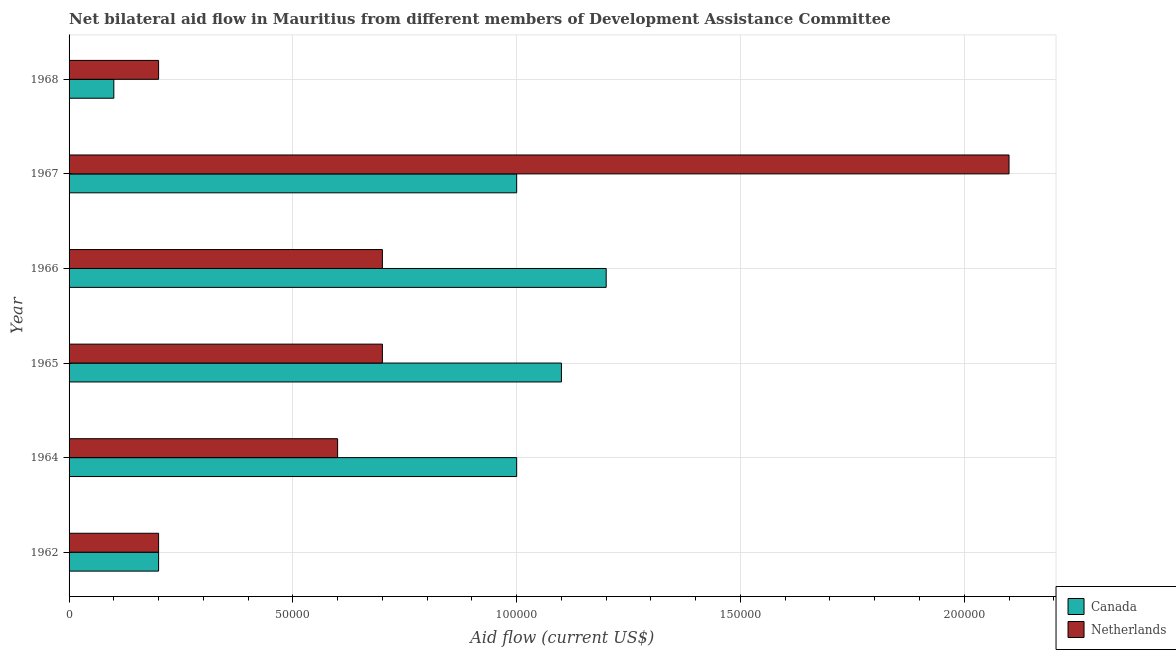How many groups of bars are there?
Provide a succinct answer. 6. Are the number of bars on each tick of the Y-axis equal?
Your response must be concise. Yes. How many bars are there on the 5th tick from the bottom?
Your answer should be compact. 2. What is the label of the 4th group of bars from the top?
Your answer should be compact. 1965. In how many cases, is the number of bars for a given year not equal to the number of legend labels?
Your answer should be very brief. 0. What is the amount of aid given by netherlands in 1962?
Provide a succinct answer. 2.00e+04. Across all years, what is the maximum amount of aid given by netherlands?
Give a very brief answer. 2.10e+05. Across all years, what is the minimum amount of aid given by netherlands?
Make the answer very short. 2.00e+04. In which year was the amount of aid given by canada maximum?
Offer a terse response. 1966. In which year was the amount of aid given by netherlands minimum?
Provide a short and direct response. 1962. What is the total amount of aid given by canada in the graph?
Give a very brief answer. 4.60e+05. What is the difference between the amount of aid given by netherlands in 1965 and that in 1966?
Provide a succinct answer. 0. What is the difference between the amount of aid given by canada in 1965 and the amount of aid given by netherlands in 1967?
Provide a short and direct response. -1.00e+05. What is the average amount of aid given by canada per year?
Provide a short and direct response. 7.67e+04. In the year 1965, what is the difference between the amount of aid given by netherlands and amount of aid given by canada?
Provide a succinct answer. -4.00e+04. In how many years, is the amount of aid given by netherlands greater than 120000 US$?
Your answer should be very brief. 1. What is the ratio of the amount of aid given by canada in 1967 to that in 1968?
Your answer should be very brief. 10. What is the difference between the highest and the lowest amount of aid given by netherlands?
Your answer should be compact. 1.90e+05. Is the sum of the amount of aid given by netherlands in 1965 and 1968 greater than the maximum amount of aid given by canada across all years?
Provide a succinct answer. No. What does the 1st bar from the top in 1967 represents?
Your response must be concise. Netherlands. What does the 2nd bar from the bottom in 1967 represents?
Make the answer very short. Netherlands. How many bars are there?
Keep it short and to the point. 12. Are all the bars in the graph horizontal?
Offer a very short reply. Yes. Does the graph contain any zero values?
Provide a succinct answer. No. Does the graph contain grids?
Keep it short and to the point. Yes. Where does the legend appear in the graph?
Provide a short and direct response. Bottom right. What is the title of the graph?
Ensure brevity in your answer.  Net bilateral aid flow in Mauritius from different members of Development Assistance Committee. Does "Services" appear as one of the legend labels in the graph?
Provide a short and direct response. No. What is the label or title of the Y-axis?
Your response must be concise. Year. What is the Aid flow (current US$) of Canada in 1962?
Ensure brevity in your answer.  2.00e+04. What is the Aid flow (current US$) in Netherlands in 1962?
Ensure brevity in your answer.  2.00e+04. What is the Aid flow (current US$) of Canada in 1965?
Provide a succinct answer. 1.10e+05. What is the Aid flow (current US$) of Netherlands in 1965?
Ensure brevity in your answer.  7.00e+04. What is the Aid flow (current US$) of Canada in 1966?
Keep it short and to the point. 1.20e+05. What is the Aid flow (current US$) of Netherlands in 1966?
Ensure brevity in your answer.  7.00e+04. What is the Aid flow (current US$) of Canada in 1967?
Your answer should be compact. 1.00e+05. What is the Aid flow (current US$) in Netherlands in 1968?
Offer a terse response. 2.00e+04. Across all years, what is the maximum Aid flow (current US$) of Canada?
Provide a succinct answer. 1.20e+05. Across all years, what is the maximum Aid flow (current US$) of Netherlands?
Give a very brief answer. 2.10e+05. Across all years, what is the minimum Aid flow (current US$) in Netherlands?
Your answer should be compact. 2.00e+04. What is the difference between the Aid flow (current US$) of Netherlands in 1962 and that in 1964?
Offer a terse response. -4.00e+04. What is the difference between the Aid flow (current US$) in Netherlands in 1962 and that in 1965?
Keep it short and to the point. -5.00e+04. What is the difference between the Aid flow (current US$) of Canada in 1962 and that in 1967?
Make the answer very short. -8.00e+04. What is the difference between the Aid flow (current US$) of Netherlands in 1964 and that in 1966?
Give a very brief answer. -10000. What is the difference between the Aid flow (current US$) of Canada in 1964 and that in 1967?
Your answer should be compact. 0. What is the difference between the Aid flow (current US$) of Netherlands in 1964 and that in 1967?
Offer a terse response. -1.50e+05. What is the difference between the Aid flow (current US$) of Canada in 1964 and that in 1968?
Offer a terse response. 9.00e+04. What is the difference between the Aid flow (current US$) in Netherlands in 1965 and that in 1967?
Offer a terse response. -1.40e+05. What is the difference between the Aid flow (current US$) of Canada in 1966 and that in 1967?
Offer a very short reply. 2.00e+04. What is the difference between the Aid flow (current US$) of Netherlands in 1966 and that in 1967?
Give a very brief answer. -1.40e+05. What is the difference between the Aid flow (current US$) in Netherlands in 1967 and that in 1968?
Make the answer very short. 1.90e+05. What is the difference between the Aid flow (current US$) of Canada in 1962 and the Aid flow (current US$) of Netherlands in 1964?
Offer a terse response. -4.00e+04. What is the difference between the Aid flow (current US$) of Canada in 1962 and the Aid flow (current US$) of Netherlands in 1965?
Keep it short and to the point. -5.00e+04. What is the difference between the Aid flow (current US$) of Canada in 1962 and the Aid flow (current US$) of Netherlands in 1966?
Your response must be concise. -5.00e+04. What is the difference between the Aid flow (current US$) in Canada in 1962 and the Aid flow (current US$) in Netherlands in 1968?
Make the answer very short. 0. What is the difference between the Aid flow (current US$) of Canada in 1964 and the Aid flow (current US$) of Netherlands in 1967?
Make the answer very short. -1.10e+05. What is the difference between the Aid flow (current US$) in Canada in 1964 and the Aid flow (current US$) in Netherlands in 1968?
Ensure brevity in your answer.  8.00e+04. What is the difference between the Aid flow (current US$) in Canada in 1965 and the Aid flow (current US$) in Netherlands in 1968?
Your answer should be very brief. 9.00e+04. What is the average Aid flow (current US$) of Canada per year?
Offer a very short reply. 7.67e+04. What is the average Aid flow (current US$) in Netherlands per year?
Provide a short and direct response. 7.50e+04. In the year 1962, what is the difference between the Aid flow (current US$) in Canada and Aid flow (current US$) in Netherlands?
Give a very brief answer. 0. In the year 1966, what is the difference between the Aid flow (current US$) of Canada and Aid flow (current US$) of Netherlands?
Your response must be concise. 5.00e+04. What is the ratio of the Aid flow (current US$) of Netherlands in 1962 to that in 1964?
Your response must be concise. 0.33. What is the ratio of the Aid flow (current US$) in Canada in 1962 to that in 1965?
Provide a succinct answer. 0.18. What is the ratio of the Aid flow (current US$) in Netherlands in 1962 to that in 1965?
Offer a very short reply. 0.29. What is the ratio of the Aid flow (current US$) of Canada in 1962 to that in 1966?
Make the answer very short. 0.17. What is the ratio of the Aid flow (current US$) in Netherlands in 1962 to that in 1966?
Offer a terse response. 0.29. What is the ratio of the Aid flow (current US$) of Canada in 1962 to that in 1967?
Your answer should be compact. 0.2. What is the ratio of the Aid flow (current US$) in Netherlands in 1962 to that in 1967?
Ensure brevity in your answer.  0.1. What is the ratio of the Aid flow (current US$) of Canada in 1962 to that in 1968?
Provide a short and direct response. 2. What is the ratio of the Aid flow (current US$) in Netherlands in 1962 to that in 1968?
Give a very brief answer. 1. What is the ratio of the Aid flow (current US$) of Canada in 1964 to that in 1965?
Offer a terse response. 0.91. What is the ratio of the Aid flow (current US$) of Canada in 1964 to that in 1966?
Offer a terse response. 0.83. What is the ratio of the Aid flow (current US$) in Netherlands in 1964 to that in 1966?
Offer a terse response. 0.86. What is the ratio of the Aid flow (current US$) in Netherlands in 1964 to that in 1967?
Provide a short and direct response. 0.29. What is the ratio of the Aid flow (current US$) in Netherlands in 1964 to that in 1968?
Provide a short and direct response. 3. What is the ratio of the Aid flow (current US$) in Netherlands in 1965 to that in 1966?
Give a very brief answer. 1. What is the ratio of the Aid flow (current US$) of Canada in 1965 to that in 1967?
Provide a succinct answer. 1.1. What is the ratio of the Aid flow (current US$) of Canada in 1966 to that in 1967?
Keep it short and to the point. 1.2. What is the ratio of the Aid flow (current US$) in Netherlands in 1966 to that in 1967?
Offer a terse response. 0.33. What is the ratio of the Aid flow (current US$) in Canada in 1966 to that in 1968?
Offer a very short reply. 12. What is the ratio of the Aid flow (current US$) of Canada in 1967 to that in 1968?
Ensure brevity in your answer.  10. What is the ratio of the Aid flow (current US$) of Netherlands in 1967 to that in 1968?
Your response must be concise. 10.5. What is the difference between the highest and the second highest Aid flow (current US$) in Canada?
Give a very brief answer. 10000. What is the difference between the highest and the lowest Aid flow (current US$) in Canada?
Your answer should be very brief. 1.10e+05. 